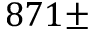Convert formula to latex. <formula><loc_0><loc_0><loc_500><loc_500>8 7 1 \pm</formula> 